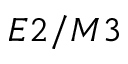<formula> <loc_0><loc_0><loc_500><loc_500>E 2 / M 3</formula> 